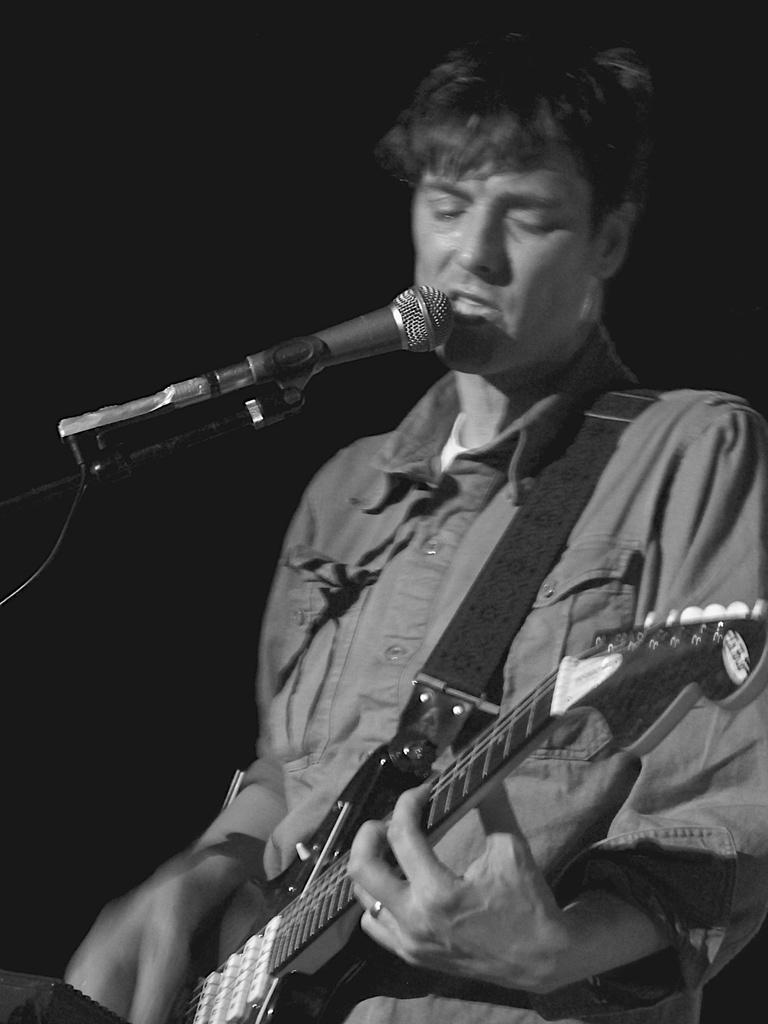Who is the main subject in the image? There is a man in the image. What is the man doing in the image? The man is standing and playing a guitar. What object is present in the image that is typically used for amplifying sound? There is a microphone in the image. Where is the cow located in the image? There is no cow present in the image. How many feet does the man have in the image? The image does not show the man's feet, so it cannot be determined from the image. 